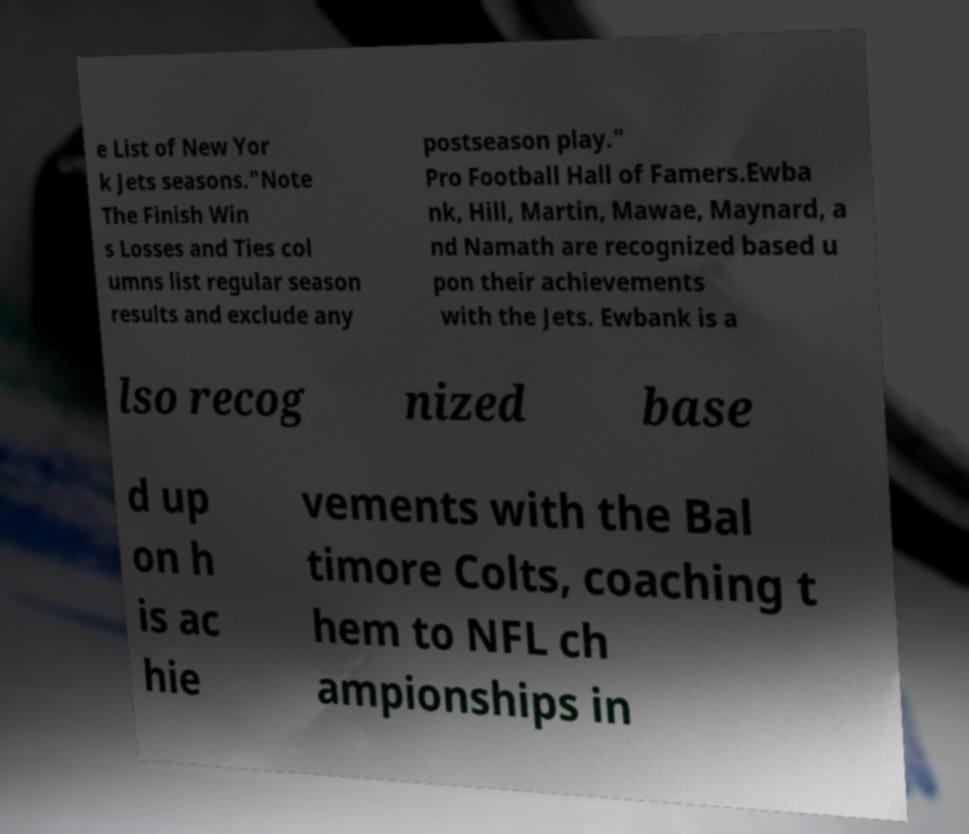Could you extract and type out the text from this image? e List of New Yor k Jets seasons."Note The Finish Win s Losses and Ties col umns list regular season results and exclude any postseason play." Pro Football Hall of Famers.Ewba nk, Hill, Martin, Mawae, Maynard, a nd Namath are recognized based u pon their achievements with the Jets. Ewbank is a lso recog nized base d up on h is ac hie vements with the Bal timore Colts, coaching t hem to NFL ch ampionships in 